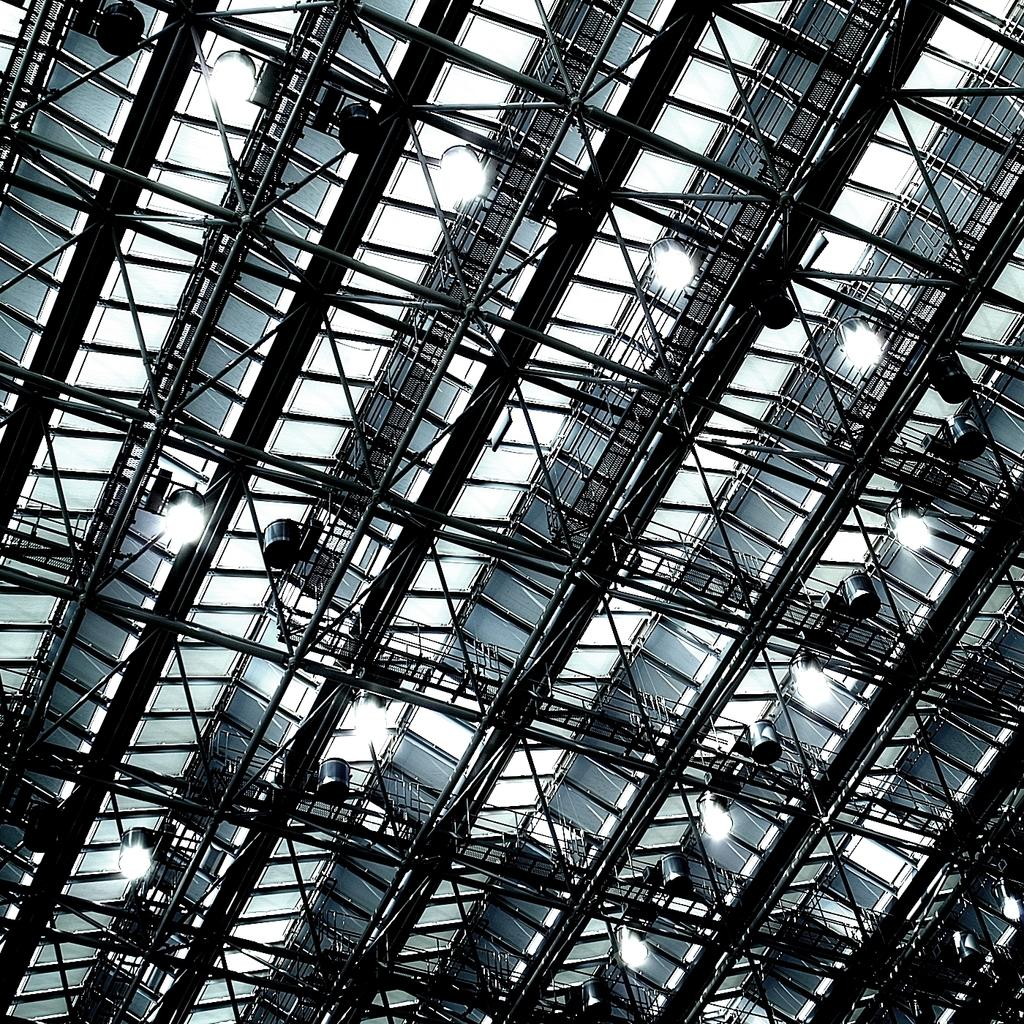What is present on top of the structure in the image? There is a roof in the image. What can be found on the roof? There are ceiling lights on the roof. What type of material is used for the frames in the image? There are metal frames visible in the image. What type of apparatus is used to control the throne in the image? There is no throne present in the image, so there is no apparatus to control it. 